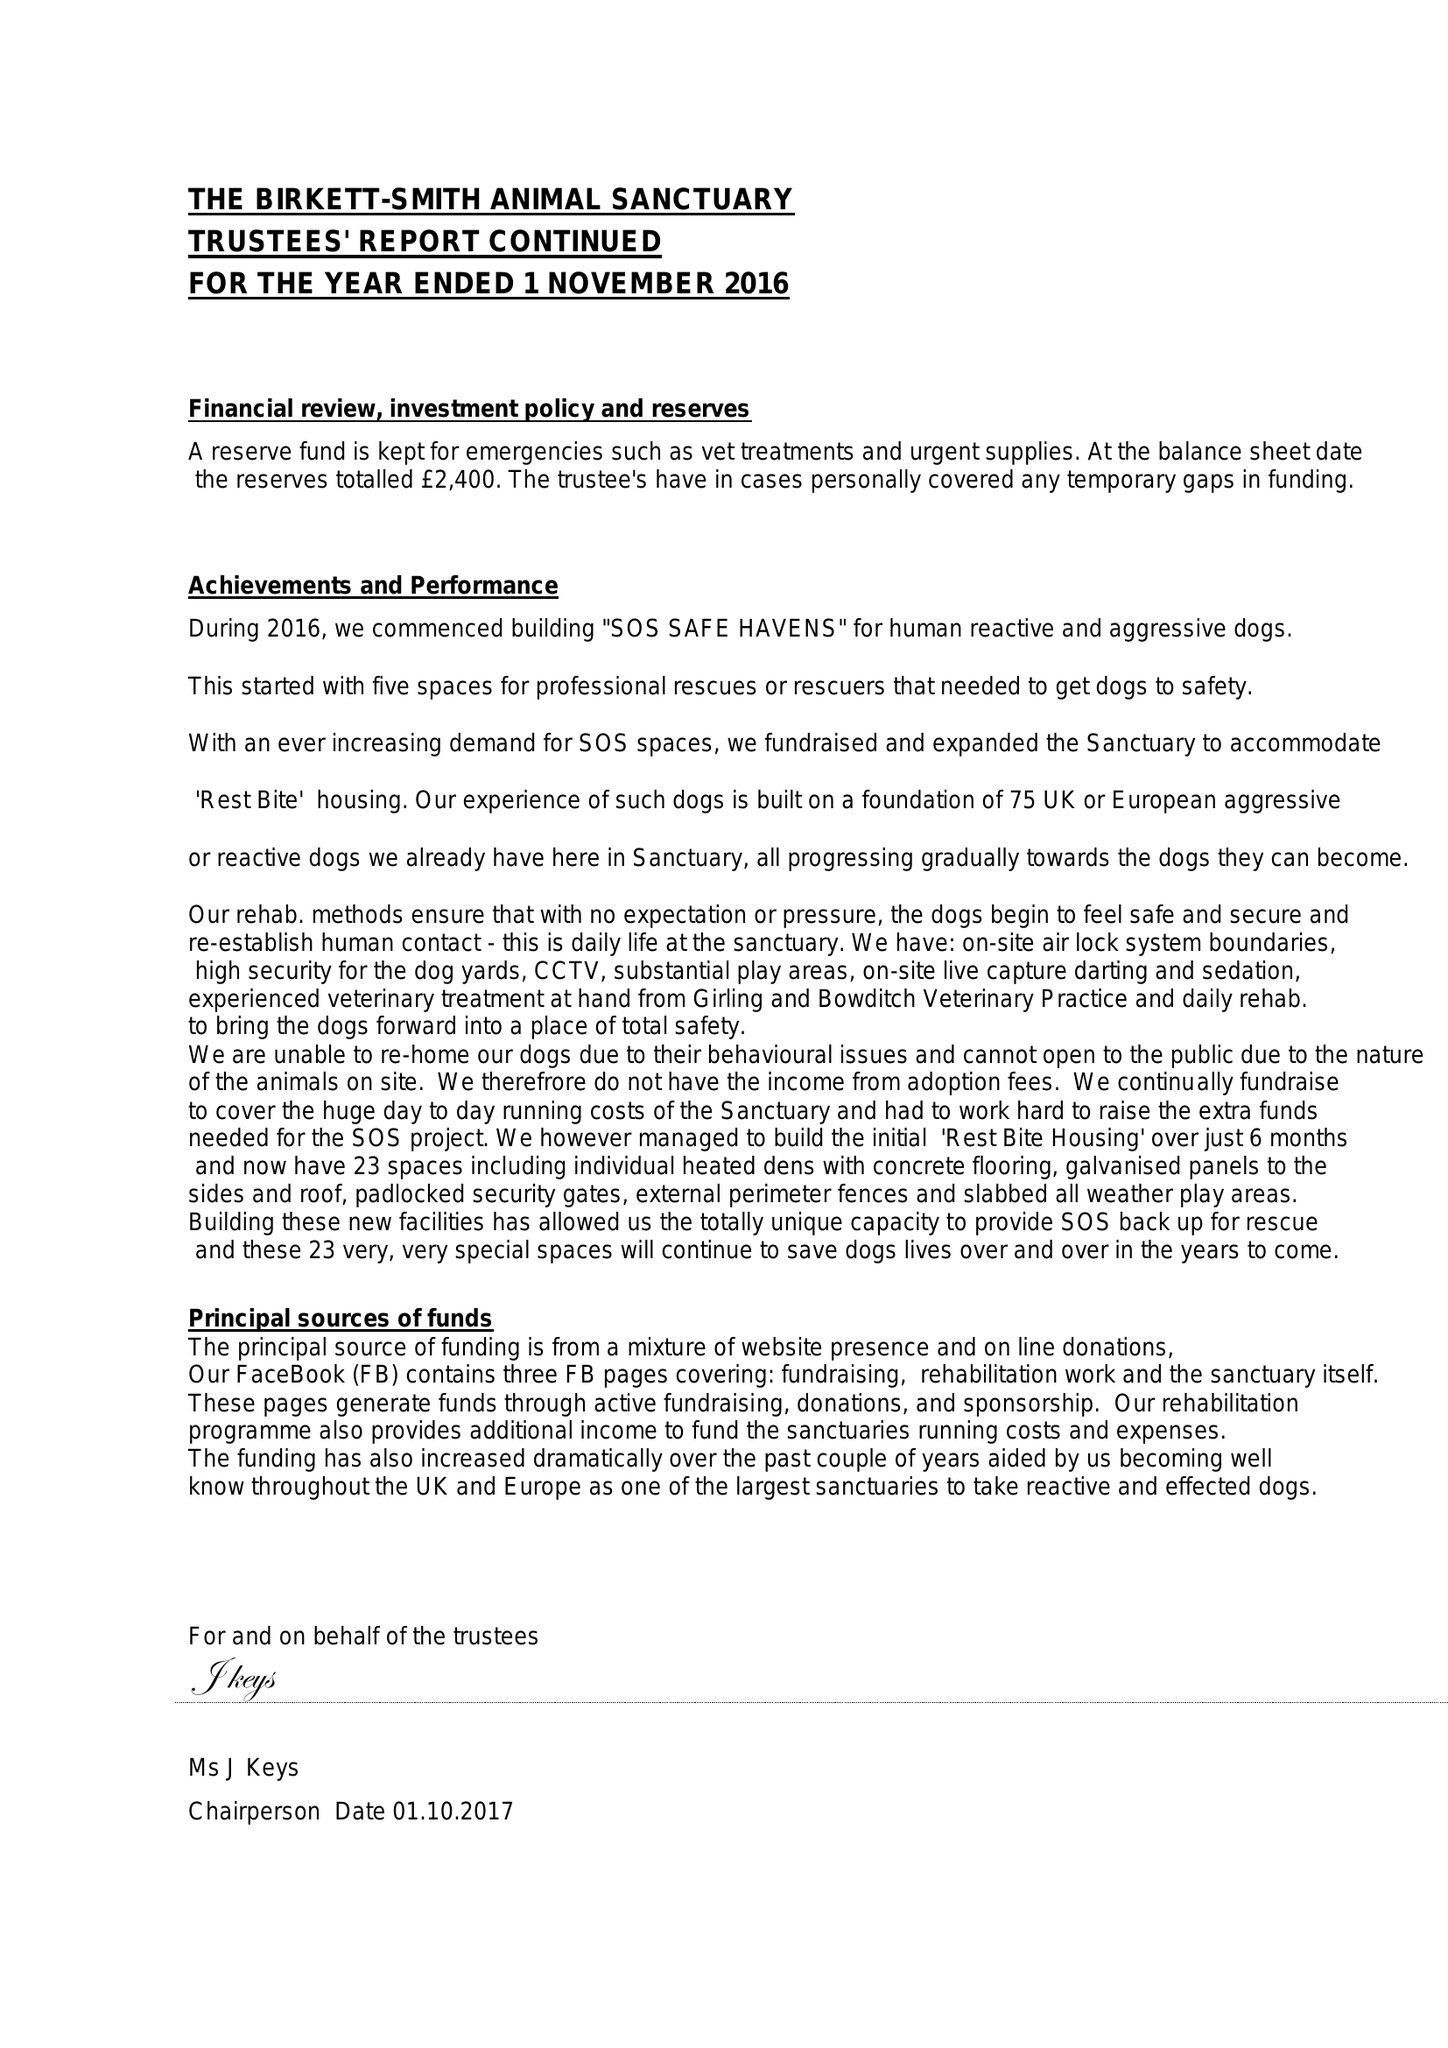What is the value for the spending_annually_in_british_pounds?
Answer the question using a single word or phrase. 100405.00 